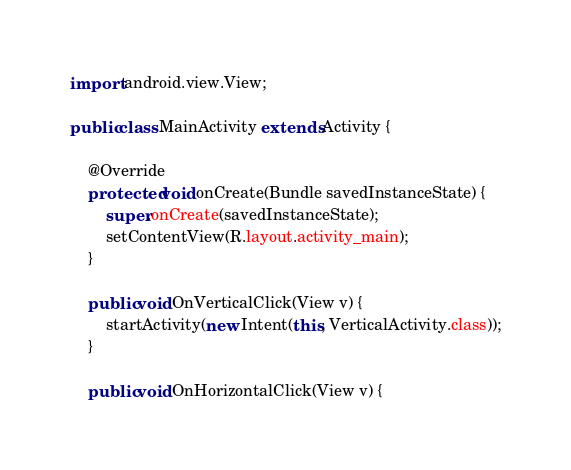Convert code to text. <code><loc_0><loc_0><loc_500><loc_500><_Java_>import android.view.View;

public class MainActivity extends Activity {

    @Override
    protected void onCreate(Bundle savedInstanceState) {
        super.onCreate(savedInstanceState);
        setContentView(R.layout.activity_main);
    }

    public void OnVerticalClick(View v) {
        startActivity(new Intent(this, VerticalActivity.class));
    }

    public void OnHorizontalClick(View v) {</code> 